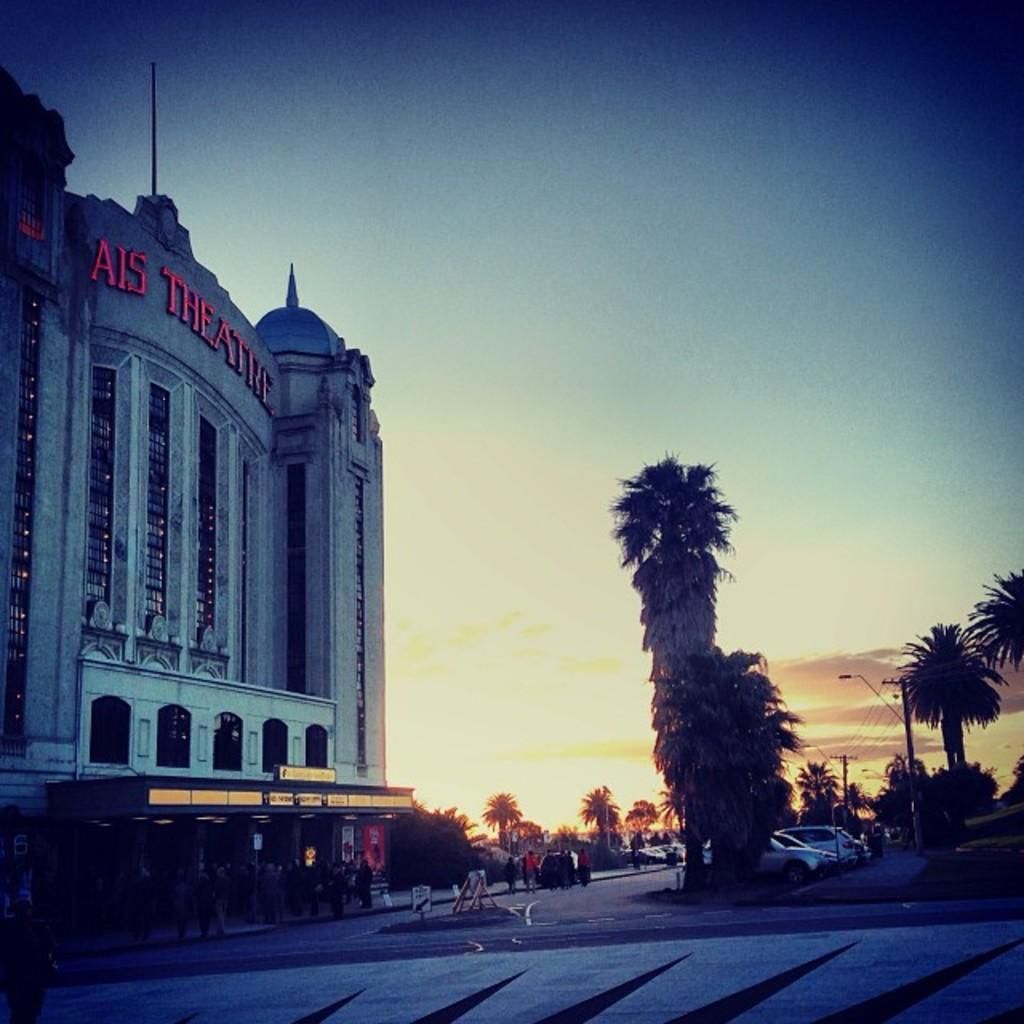What is the setting of the image? The image is an outside view. What can be seen at the bottom of the image? There is a road at the bottom of the image. What type of vegetation is visible in the image? There are many trees visible in the image. What is moving along the road in the image? There are vehicles on the road. What structure is located on the left side of the image? There is a building on the left side of the image. What is visible at the top of the image? The sky is visible at the top of the image. What type of note is being played by the pet in the image? There is no pet or note being played in the image; it features an outside view with a road, trees, vehicles, a building, and the sky. 